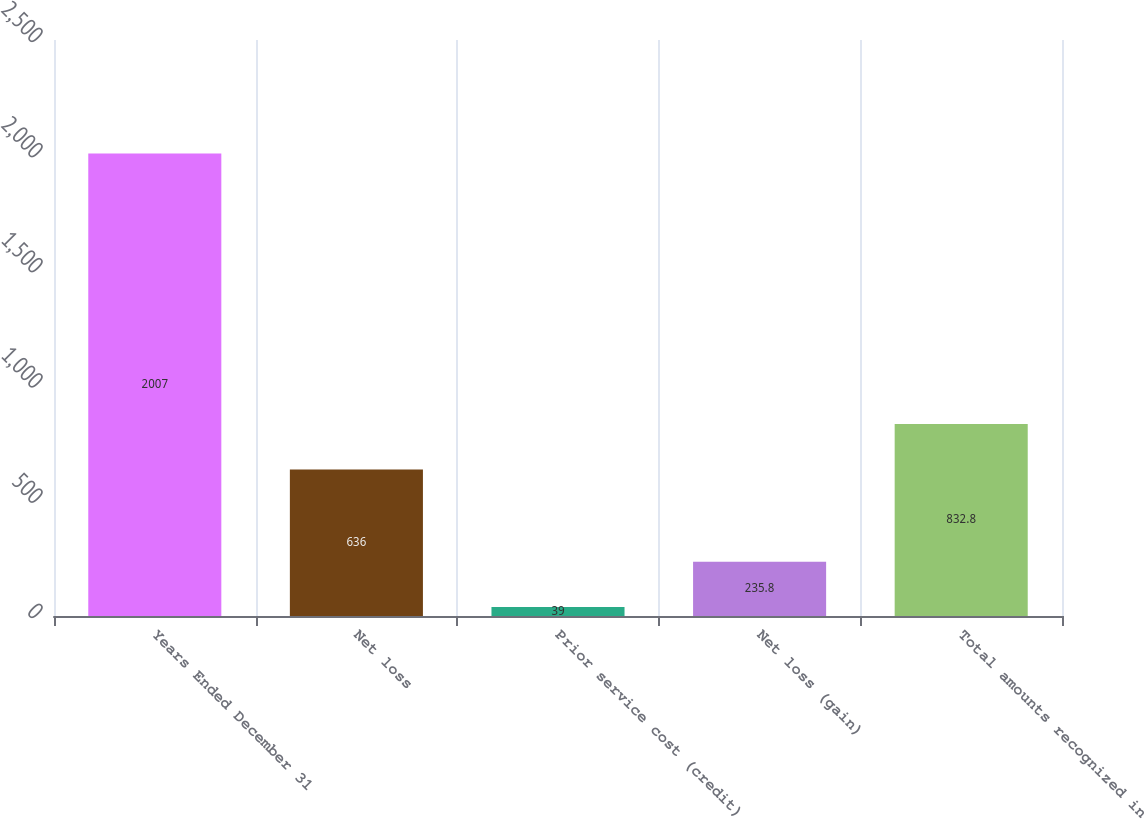Convert chart. <chart><loc_0><loc_0><loc_500><loc_500><bar_chart><fcel>Years Ended December 31<fcel>Net loss<fcel>Prior service cost (credit)<fcel>Net loss (gain)<fcel>Total amounts recognized in<nl><fcel>2007<fcel>636<fcel>39<fcel>235.8<fcel>832.8<nl></chart> 